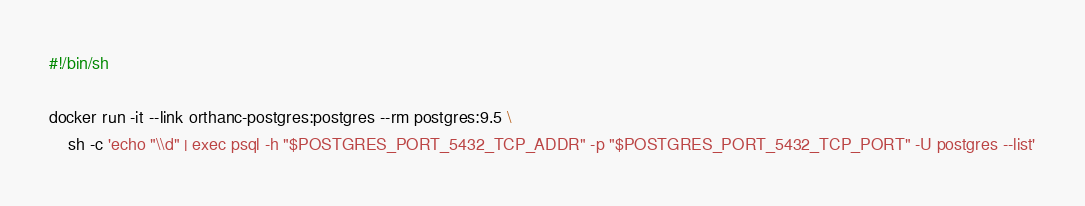<code> <loc_0><loc_0><loc_500><loc_500><_Bash_>#!/bin/sh

docker run -it --link orthanc-postgres:postgres --rm postgres:9.5 \
	sh -c 'echo "\\d" | exec psql -h "$POSTGRES_PORT_5432_TCP_ADDR" -p "$POSTGRES_PORT_5432_TCP_PORT" -U postgres --list'
</code> 